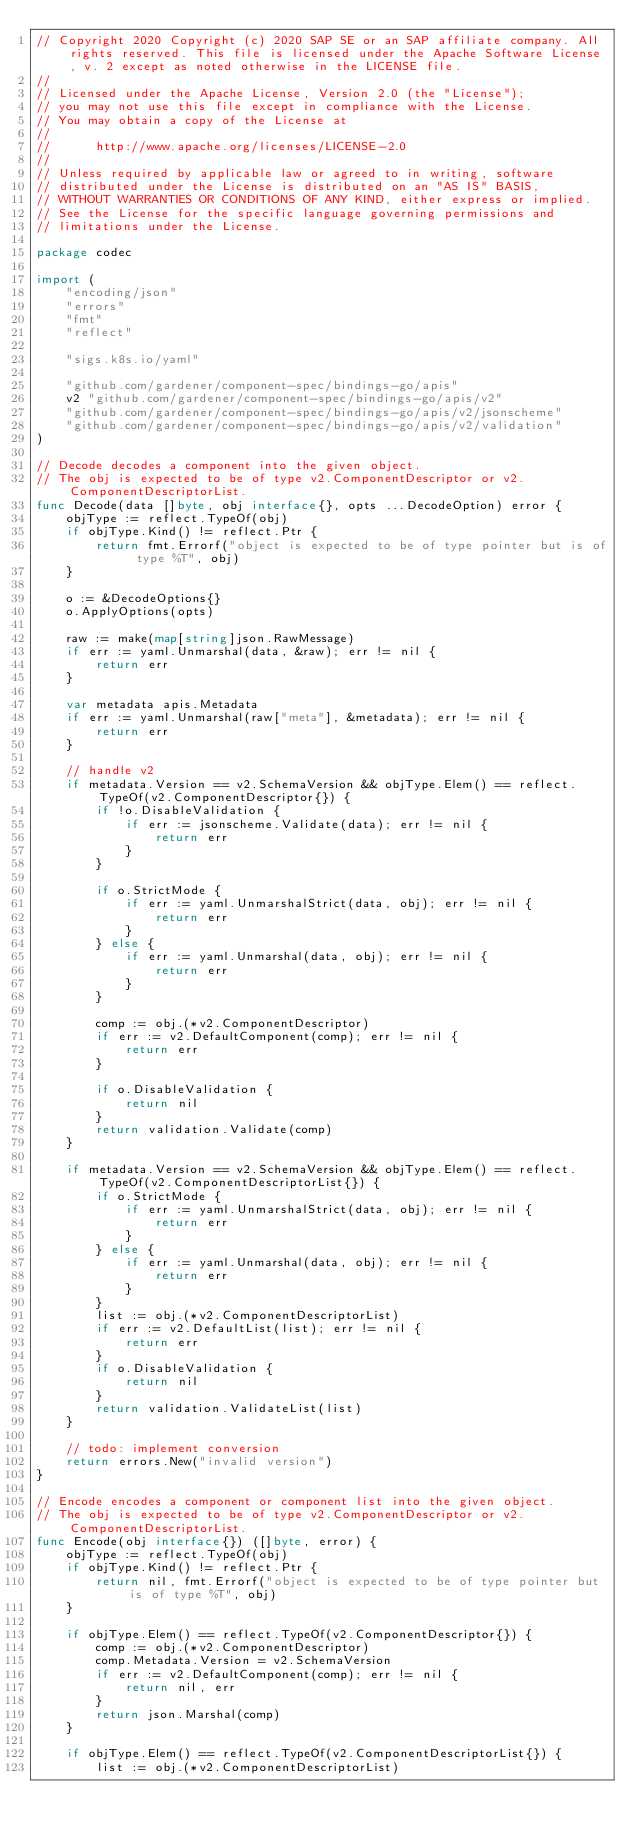<code> <loc_0><loc_0><loc_500><loc_500><_Go_>// Copyright 2020 Copyright (c) 2020 SAP SE or an SAP affiliate company. All rights reserved. This file is licensed under the Apache Software License, v. 2 except as noted otherwise in the LICENSE file.
//
// Licensed under the Apache License, Version 2.0 (the "License");
// you may not use this file except in compliance with the License.
// You may obtain a copy of the License at
//
//      http://www.apache.org/licenses/LICENSE-2.0
//
// Unless required by applicable law or agreed to in writing, software
// distributed under the License is distributed on an "AS IS" BASIS,
// WITHOUT WARRANTIES OR CONDITIONS OF ANY KIND, either express or implied.
// See the License for the specific language governing permissions and
// limitations under the License.

package codec

import (
	"encoding/json"
	"errors"
	"fmt"
	"reflect"

	"sigs.k8s.io/yaml"

	"github.com/gardener/component-spec/bindings-go/apis"
	v2 "github.com/gardener/component-spec/bindings-go/apis/v2"
	"github.com/gardener/component-spec/bindings-go/apis/v2/jsonscheme"
	"github.com/gardener/component-spec/bindings-go/apis/v2/validation"
)

// Decode decodes a component into the given object.
// The obj is expected to be of type v2.ComponentDescriptor or v2.ComponentDescriptorList.
func Decode(data []byte, obj interface{}, opts ...DecodeOption) error {
	objType := reflect.TypeOf(obj)
	if objType.Kind() != reflect.Ptr {
		return fmt.Errorf("object is expected to be of type pointer but is of type %T", obj)
	}

	o := &DecodeOptions{}
	o.ApplyOptions(opts)

	raw := make(map[string]json.RawMessage)
	if err := yaml.Unmarshal(data, &raw); err != nil {
		return err
	}

	var metadata apis.Metadata
	if err := yaml.Unmarshal(raw["meta"], &metadata); err != nil {
		return err
	}

	// handle v2
	if metadata.Version == v2.SchemaVersion && objType.Elem() == reflect.TypeOf(v2.ComponentDescriptor{}) {
		if !o.DisableValidation {
			if err := jsonscheme.Validate(data); err != nil {
				return err
			}
		}

		if o.StrictMode {
			if err := yaml.UnmarshalStrict(data, obj); err != nil {
				return err
			}
		} else {
			if err := yaml.Unmarshal(data, obj); err != nil {
				return err
			}
		}

		comp := obj.(*v2.ComponentDescriptor)
		if err := v2.DefaultComponent(comp); err != nil {
			return err
		}

		if o.DisableValidation {
			return nil
		}
		return validation.Validate(comp)
	}

	if metadata.Version == v2.SchemaVersion && objType.Elem() == reflect.TypeOf(v2.ComponentDescriptorList{}) {
		if o.StrictMode {
			if err := yaml.UnmarshalStrict(data, obj); err != nil {
				return err
			}
		} else {
			if err := yaml.Unmarshal(data, obj); err != nil {
				return err
			}
		}
		list := obj.(*v2.ComponentDescriptorList)
		if err := v2.DefaultList(list); err != nil {
			return err
		}
		if o.DisableValidation {
			return nil
		}
		return validation.ValidateList(list)
	}

	// todo: implement conversion
	return errors.New("invalid version")
}

// Encode encodes a component or component list into the given object.
// The obj is expected to be of type v2.ComponentDescriptor or v2.ComponentDescriptorList.
func Encode(obj interface{}) ([]byte, error) {
	objType := reflect.TypeOf(obj)
	if objType.Kind() != reflect.Ptr {
		return nil, fmt.Errorf("object is expected to be of type pointer but is of type %T", obj)
	}

	if objType.Elem() == reflect.TypeOf(v2.ComponentDescriptor{}) {
		comp := obj.(*v2.ComponentDescriptor)
		comp.Metadata.Version = v2.SchemaVersion
		if err := v2.DefaultComponent(comp); err != nil {
			return nil, err
		}
		return json.Marshal(comp)
	}

	if objType.Elem() == reflect.TypeOf(v2.ComponentDescriptorList{}) {
		list := obj.(*v2.ComponentDescriptorList)</code> 